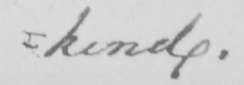Transcribe the text shown in this historical manuscript line. =kind. 